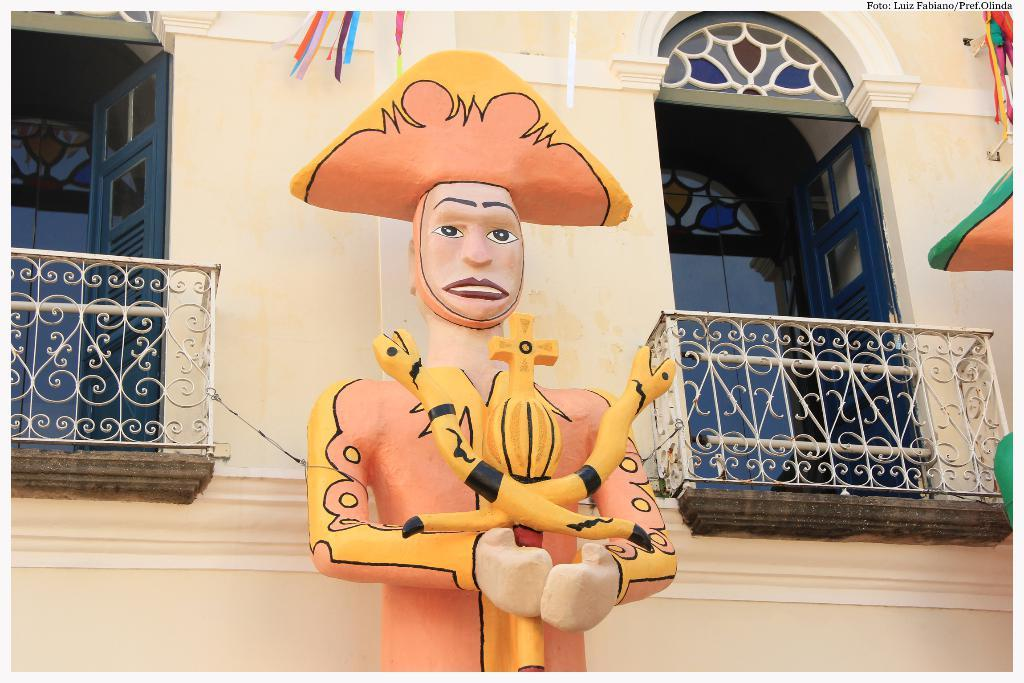What type of structure is present in the image? There is a building in the image. What artistic element can be seen in the image? There is a sculpture in the image. How many windows in blue color are visible in the image? There are two windows in blue color in the image. What grade of bread is being used to make the sculpture in the image? There is no bread or sculpture made of bread present in the image. 